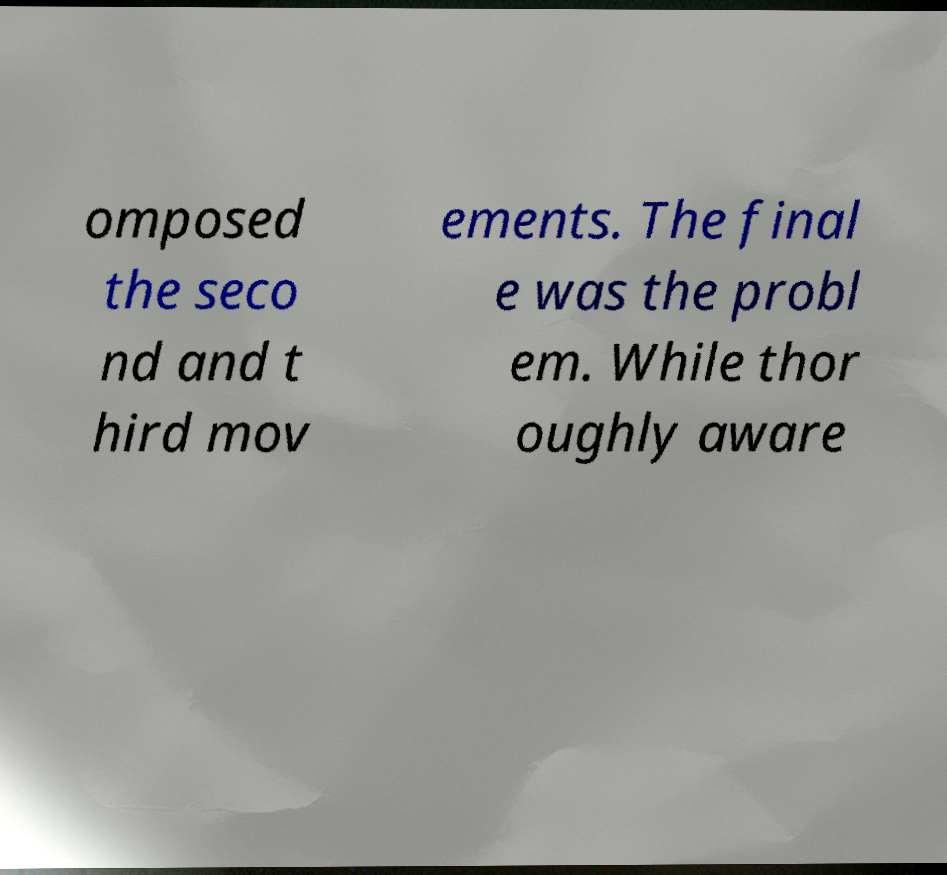Can you read and provide the text displayed in the image?This photo seems to have some interesting text. Can you extract and type it out for me? omposed the seco nd and t hird mov ements. The final e was the probl em. While thor oughly aware 